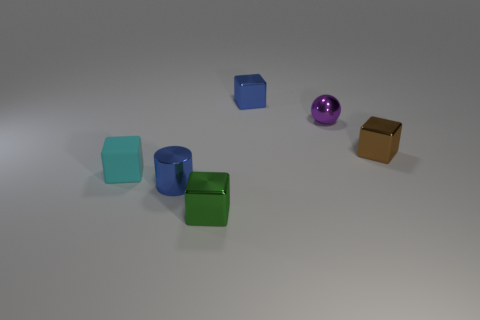There is a object that is the same color as the shiny cylinder; what is its size?
Ensure brevity in your answer.  Small. There is a shiny thing that is the same color as the shiny cylinder; what is its shape?
Give a very brief answer. Cube. What is the color of the rubber thing?
Offer a very short reply. Cyan. There is a tiny green block; are there any blue metal cubes in front of it?
Provide a succinct answer. No. Do the tiny cyan matte thing and the tiny blue thing behind the small rubber block have the same shape?
Ensure brevity in your answer.  Yes. How many other things are the same material as the blue cylinder?
Give a very brief answer. 4. What color is the small cube that is to the right of the metal block that is behind the tiny metal block to the right of the blue metal cube?
Your response must be concise. Brown. There is a blue thing that is to the left of the metal cube in front of the small brown metal thing; what shape is it?
Give a very brief answer. Cylinder. Are there more green blocks to the left of the tiny blue cylinder than tiny blue objects?
Your answer should be very brief. No. Do the blue shiny object in front of the cyan thing and the purple object have the same shape?
Offer a very short reply. No. 